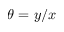<formula> <loc_0><loc_0><loc_500><loc_500>\theta = y / x</formula> 